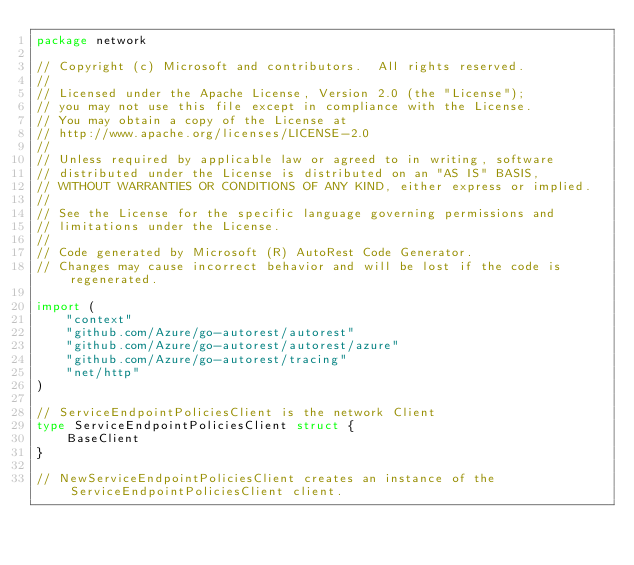<code> <loc_0><loc_0><loc_500><loc_500><_Go_>package network

// Copyright (c) Microsoft and contributors.  All rights reserved.
//
// Licensed under the Apache License, Version 2.0 (the "License");
// you may not use this file except in compliance with the License.
// You may obtain a copy of the License at
// http://www.apache.org/licenses/LICENSE-2.0
//
// Unless required by applicable law or agreed to in writing, software
// distributed under the License is distributed on an "AS IS" BASIS,
// WITHOUT WARRANTIES OR CONDITIONS OF ANY KIND, either express or implied.
//
// See the License for the specific language governing permissions and
// limitations under the License.
//
// Code generated by Microsoft (R) AutoRest Code Generator.
// Changes may cause incorrect behavior and will be lost if the code is regenerated.

import (
	"context"
	"github.com/Azure/go-autorest/autorest"
	"github.com/Azure/go-autorest/autorest/azure"
	"github.com/Azure/go-autorest/tracing"
	"net/http"
)

// ServiceEndpointPoliciesClient is the network Client
type ServiceEndpointPoliciesClient struct {
	BaseClient
}

// NewServiceEndpointPoliciesClient creates an instance of the ServiceEndpointPoliciesClient client.</code> 